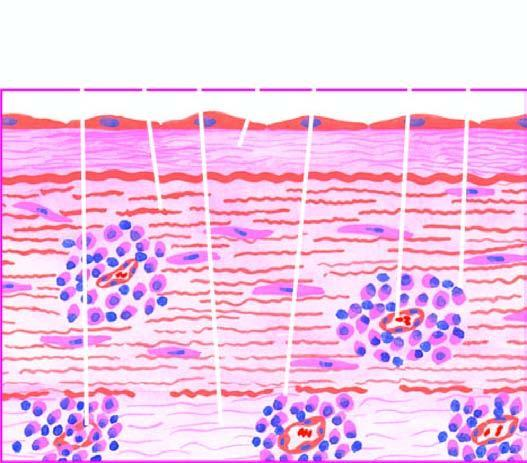s thalassaemia and hbd endarteritis and periarteritis of the vasa vasorum in the media and adventitia?
Answer the question using a single word or phrase. No 